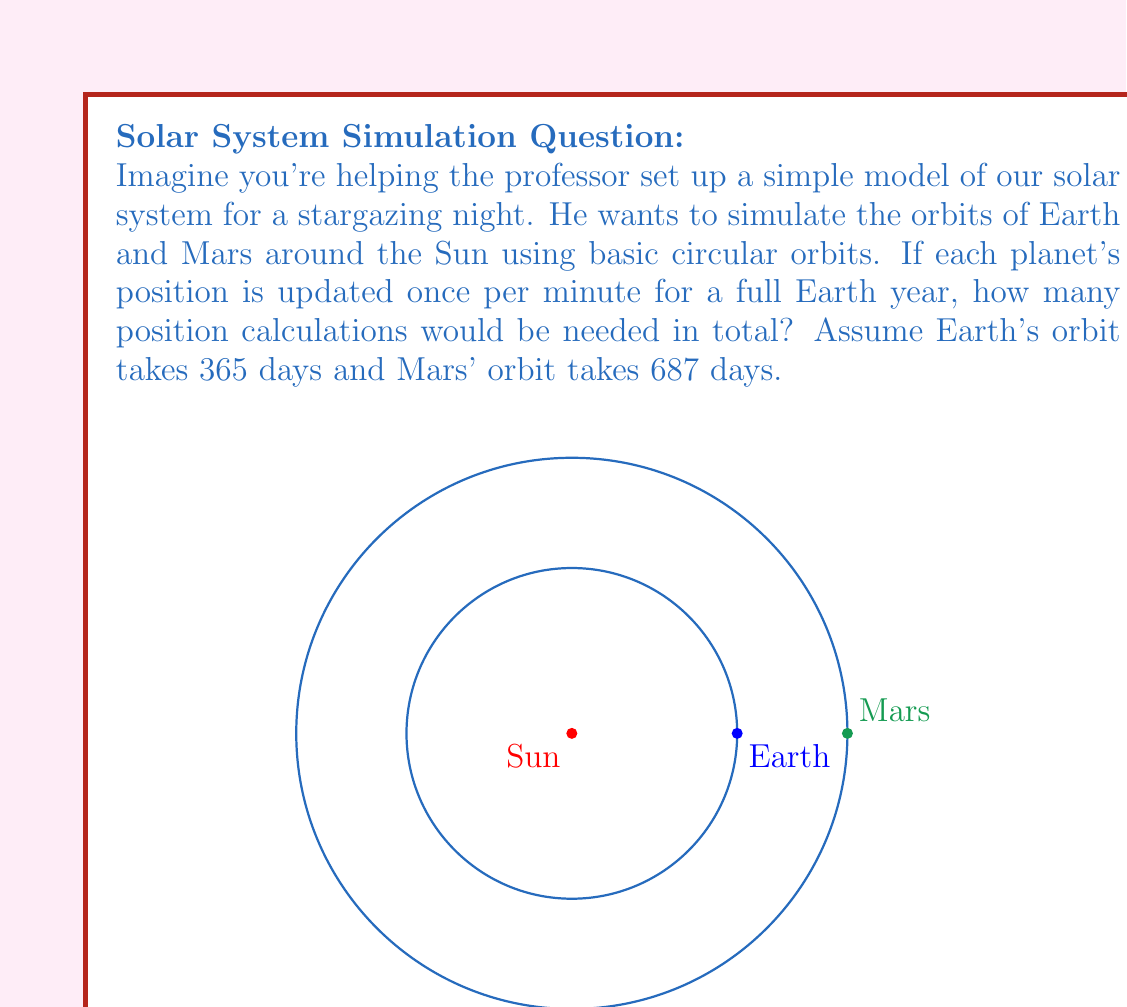Give your solution to this math problem. Let's break this down step-by-step:

1) First, we need to calculate how many minutes are in an Earth year:
   $$365 \text{ days} \times 24 \text{ hours/day} \times 60 \text{ minutes/hour} = 525,600 \text{ minutes}$$

2) For each minute, we need to calculate the position of both Earth and Mars. So for each minute, we're doing 2 calculations.

3) The total number of calculations will be:
   $$525,600 \text{ minutes} \times 2 \text{ planets} = 1,051,200 \text{ calculations}$$

4) Note that even though Mars' orbit is longer than Earth's, we only need to simulate for one Earth year in this model.

5) In terms of computational complexity, if we denote the number of minutes as $n$ and the number of planets as $p$, the complexity would be $O(np)$. In this case, $n = 525,600$ and $p = 2$.

This simple model demonstrates linear time complexity in relation to both the number of time steps and the number of planets. However, real solar system simulations are much more complex, often involving n-body problems with time complexity of $O(n^2)$ or higher.
Answer: 1,051,200 calculations 